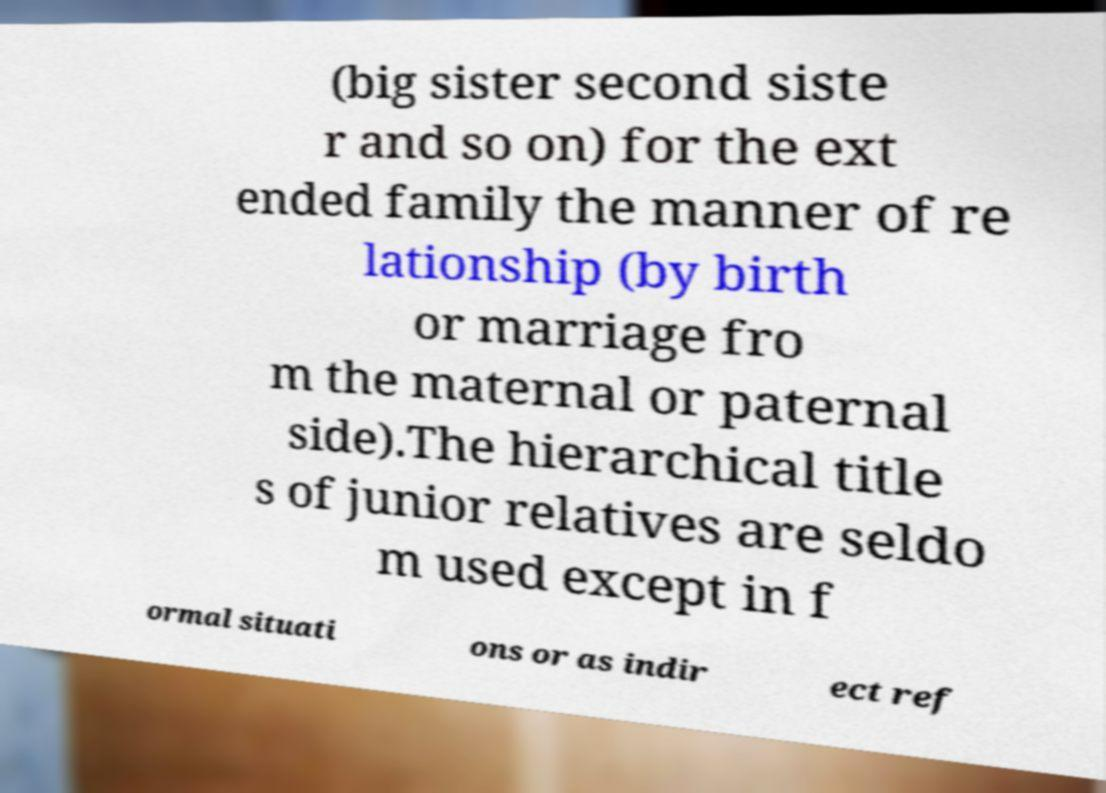Can you accurately transcribe the text from the provided image for me? (big sister second siste r and so on) for the ext ended family the manner of re lationship (by birth or marriage fro m the maternal or paternal side).The hierarchical title s of junior relatives are seldo m used except in f ormal situati ons or as indir ect ref 